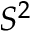Convert formula to latex. <formula><loc_0><loc_0><loc_500><loc_500>S ^ { 2 }</formula> 